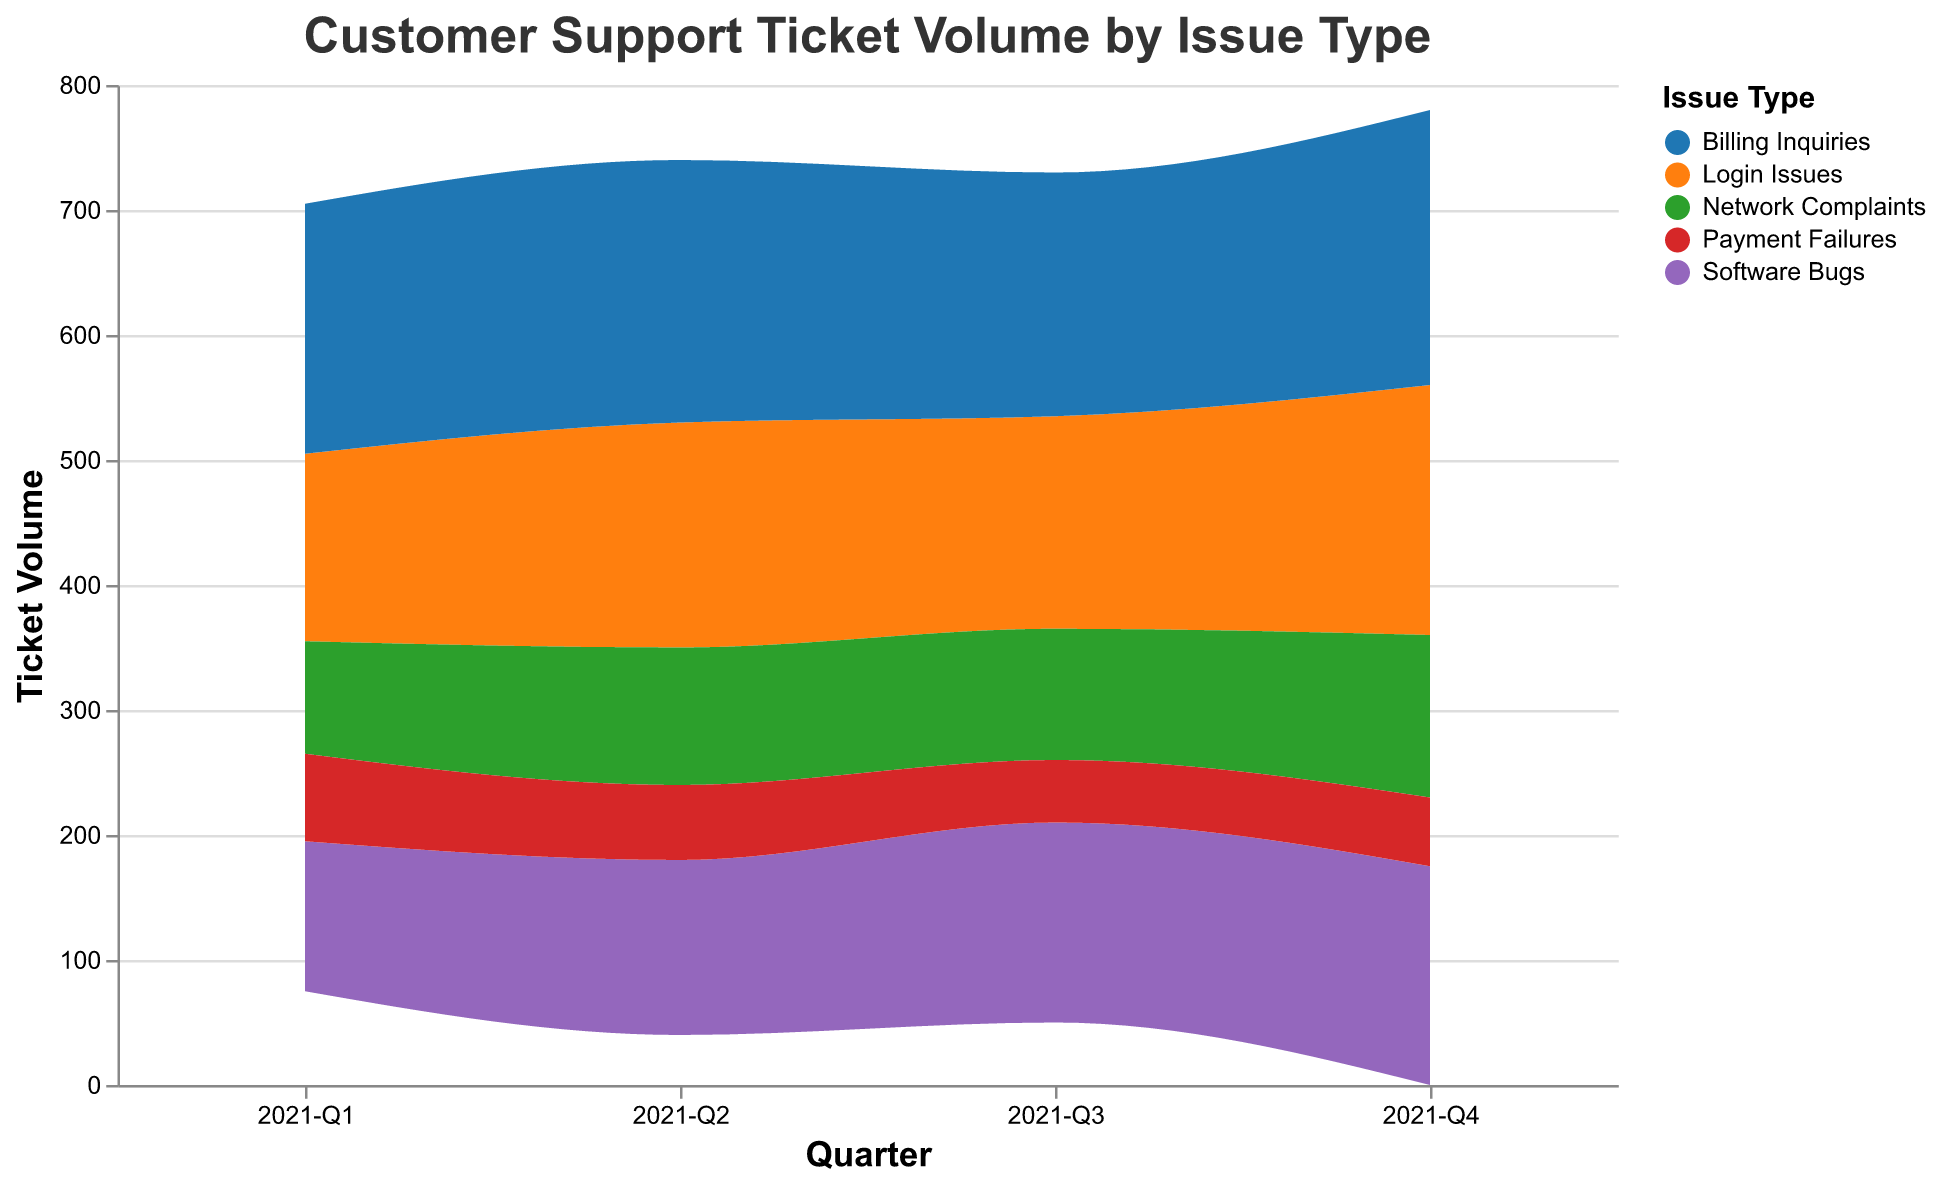What's the title of the figure? The title of the figure is displayed at the top in a larger font. It reads "Customer Support Ticket Volume by Issue Type"
Answer: Customer Support Ticket Volume by Issue Type How many Time Periods are represented in the figure? The figure has labels on the x-axis representing different time periods. There are four labels: 2021-Q1, 2021-Q2, 2021-Q3, and 2021-Q4
Answer: 4 Which Issue Type had the highest ticket volume in 2021-Q1? Observe the heights of the colored areas at the 2021-Q1 mark on the x-axis. The highest ticket volume is represented by the tallest segment, which is for "Billing Inquiries"
Answer: Billing Inquiries What was the ticket volume change for Login Issues between 2021-Q2 and 2021-Q3? Look at the figure to find the height of the Login Issues sections at 2021-Q2 and 2021-Q3, then calculate the difference: 180 - 170 = 10
Answer: Decreased by 10 Which issue type had steadily increasing volumes over the time periods? Identify the color associated with each issue type and check the trends over the four quarters. Software Bugs shows a steady increase over each time period
Answer: Software Bugs What was the total ticket volume for all issue types in 2021-Q4? Combine the volumes of all issue types in the 2021-Q4 column. Sum up: 200 (Login Issues) + 175 (Software Bugs) + 130 (Network Complaints) + 220 (Billing Inquiries) + 55 (Payment Failures) = 780
Answer: 780 Which issue type had the lowest ticket volume in any time period, and what was the volume? Examine each issue type’s volume across all periods. Payment Failures in 2021-Q3 has the lowest volume, which is 50
Answer: Payment Failures in 2021-Q3 with a volume of 50 Compare the ticket volumes for Billing Inquiries and Network Complaints in 2021-Q3. Which was higher and by how much? Check the heights for these areas in 2021-Q3. Billing Inquiries: 195, Network Complaints: 105. Subtract: 195 - 105 = 90
Answer: Billing Inquiries by 90 Which two issue types had the closest volumes in 2021-Q2 and what were they? Look at the height of the sections for 2021-Q2. Login Issues and Billing Inquiries are close. Volumes: Login Issues: 180, Billing Inquiries: 210. Difference: 210 - 180 = 30
Answer: Login Issues and Billing Inquiries with a difference of 30 How did the volume of Payment Failures change from 2021-Q1 to 2021-Q2? Observe the figure for Payment Failures from 2021-Q1 to 2021-Q2. It decreased from 70 to 60
Answer: Decreased from 70 to 60 